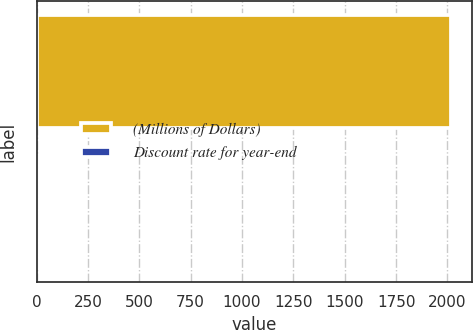Convert chart. <chart><loc_0><loc_0><loc_500><loc_500><bar_chart><fcel>(Millions of Dollars)<fcel>Discount rate for year-end<nl><fcel>2018<fcel>4.32<nl></chart> 